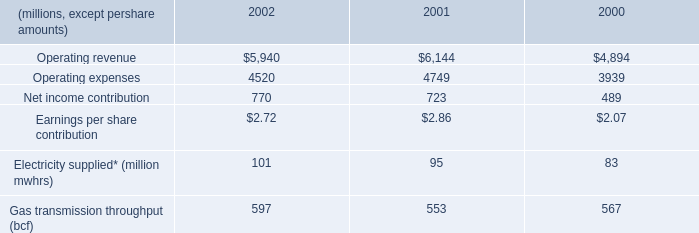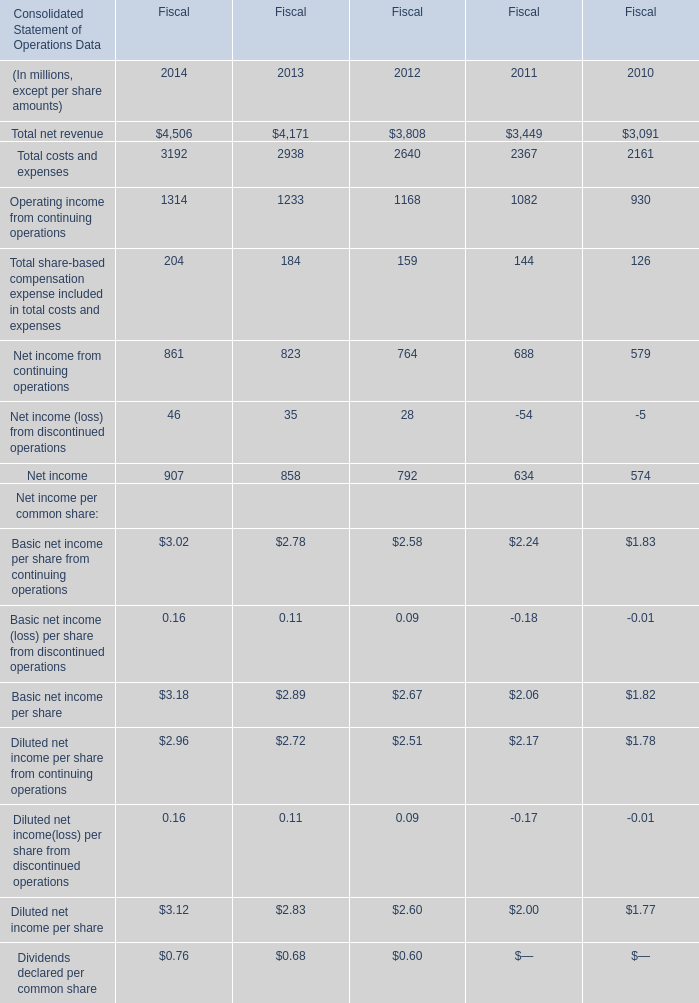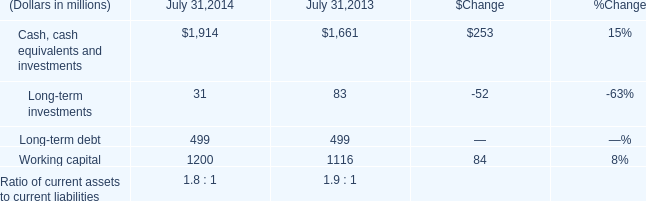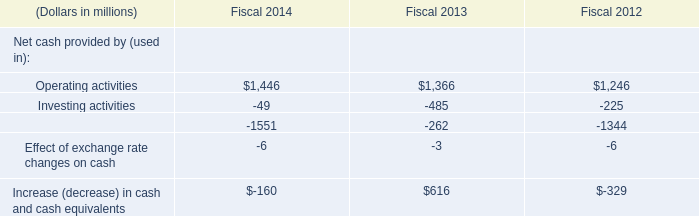What do all Total net revenue for Fiscal sum up, in the year that the total of Operating activitiesis greater than 1000? (in million) 
Computations: ((4506 + 4171) + 3808)
Answer: 12485.0. 